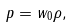<formula> <loc_0><loc_0><loc_500><loc_500>p = w _ { 0 } \rho ,</formula> 